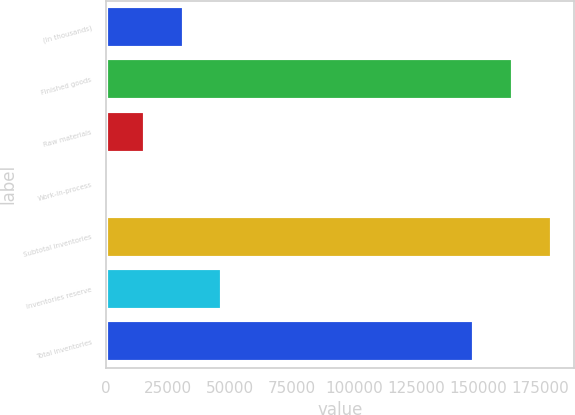Convert chart. <chart><loc_0><loc_0><loc_500><loc_500><bar_chart><fcel>(In thousands)<fcel>Finished goods<fcel>Raw materials<fcel>Work-in-process<fcel>Subtotal inventories<fcel>Inventories reserve<fcel>Total inventories<nl><fcel>31347.2<fcel>164126<fcel>15709.1<fcel>71<fcel>179764<fcel>46985.3<fcel>148488<nl></chart> 